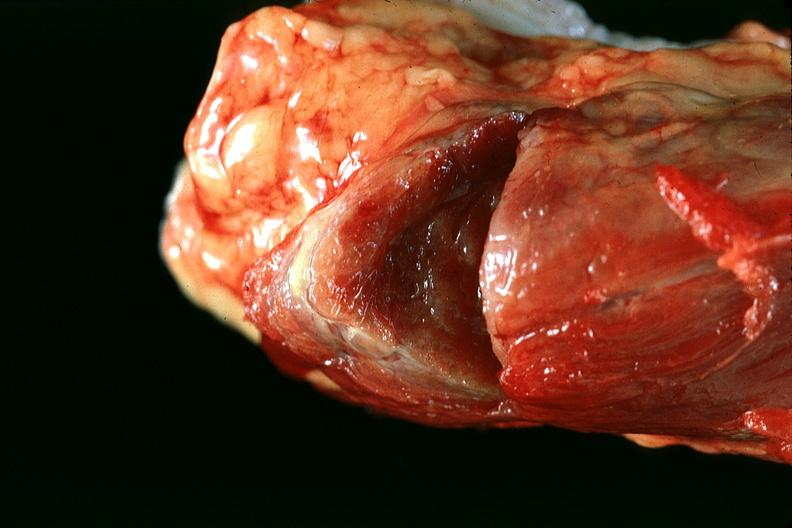where does this belong to?
Answer the question using a single word or phrase. Endocrine system 